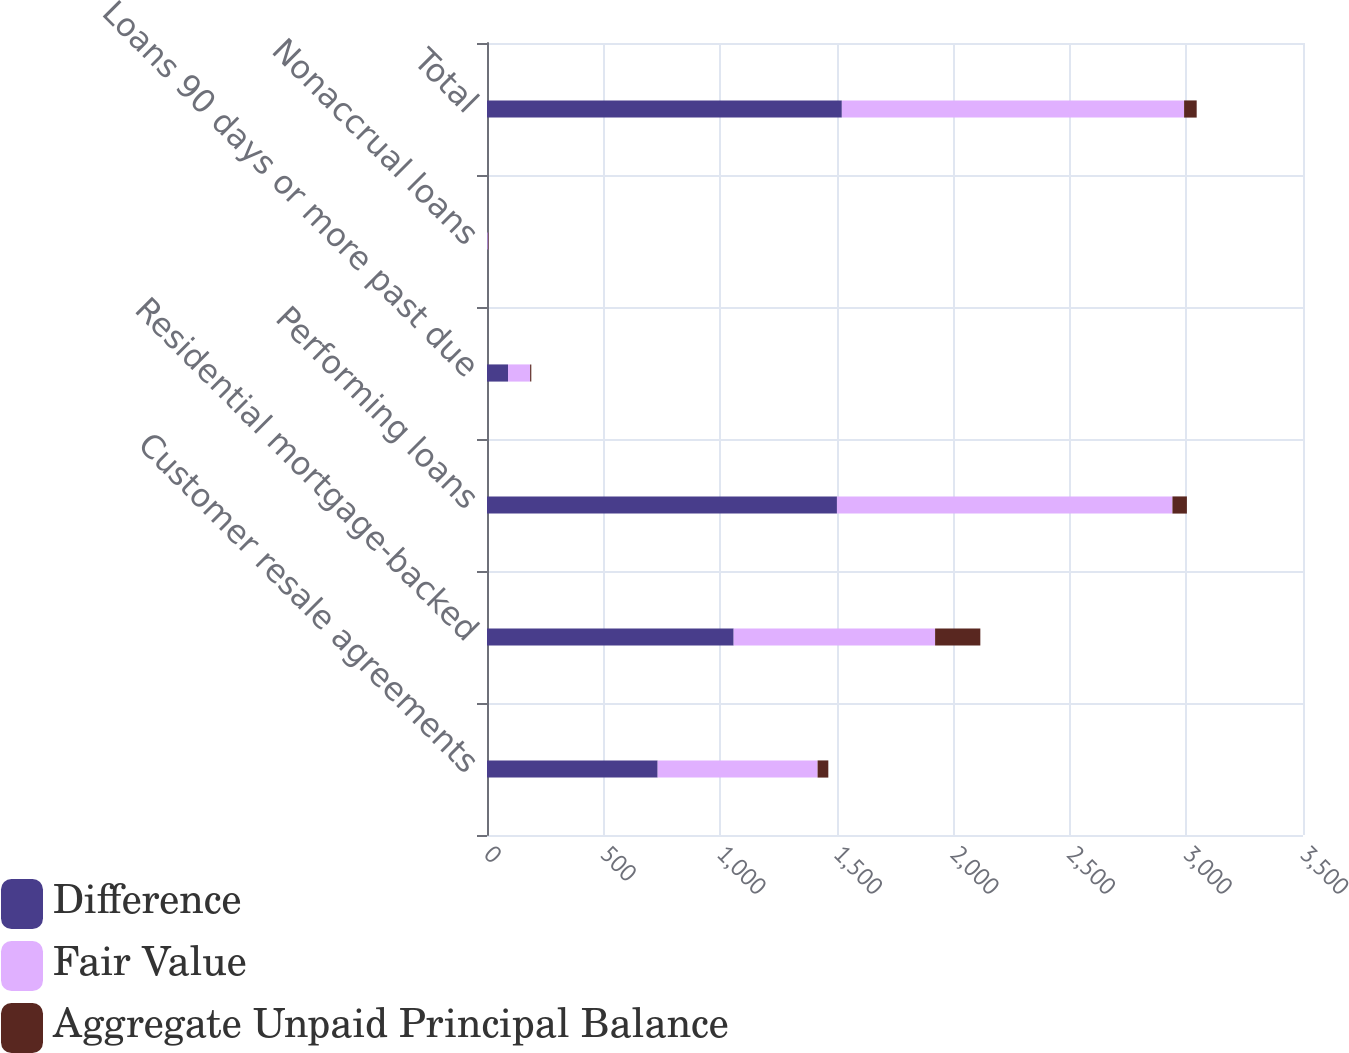Convert chart. <chart><loc_0><loc_0><loc_500><loc_500><stacked_bar_chart><ecel><fcel>Customer resale agreements<fcel>Residential mortgage-backed<fcel>Performing loans<fcel>Loans 90 days or more past due<fcel>Nonaccrual loans<fcel>Total<nl><fcel>Difference<fcel>732<fcel>1058<fcel>1501<fcel>90<fcel>2<fcel>1522<nl><fcel>Fair Value<fcel>686<fcel>864<fcel>1439<fcel>95<fcel>4<fcel>1468<nl><fcel>Aggregate Unpaid Principal Balance<fcel>46<fcel>194<fcel>62<fcel>5<fcel>2<fcel>54<nl></chart> 